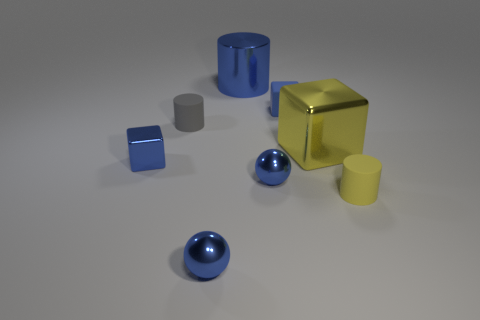Subtract all large cylinders. How many cylinders are left? 2 Subtract all yellow blocks. How many blocks are left? 2 Add 1 big blue shiny things. How many objects exist? 9 Subtract all blocks. How many objects are left? 5 Subtract 0 brown spheres. How many objects are left? 8 Subtract 1 balls. How many balls are left? 1 Subtract all blue cylinders. Subtract all brown balls. How many cylinders are left? 2 Subtract all red balls. How many blue cubes are left? 2 Subtract all yellow rubber spheres. Subtract all metallic cubes. How many objects are left? 6 Add 5 blue things. How many blue things are left? 10 